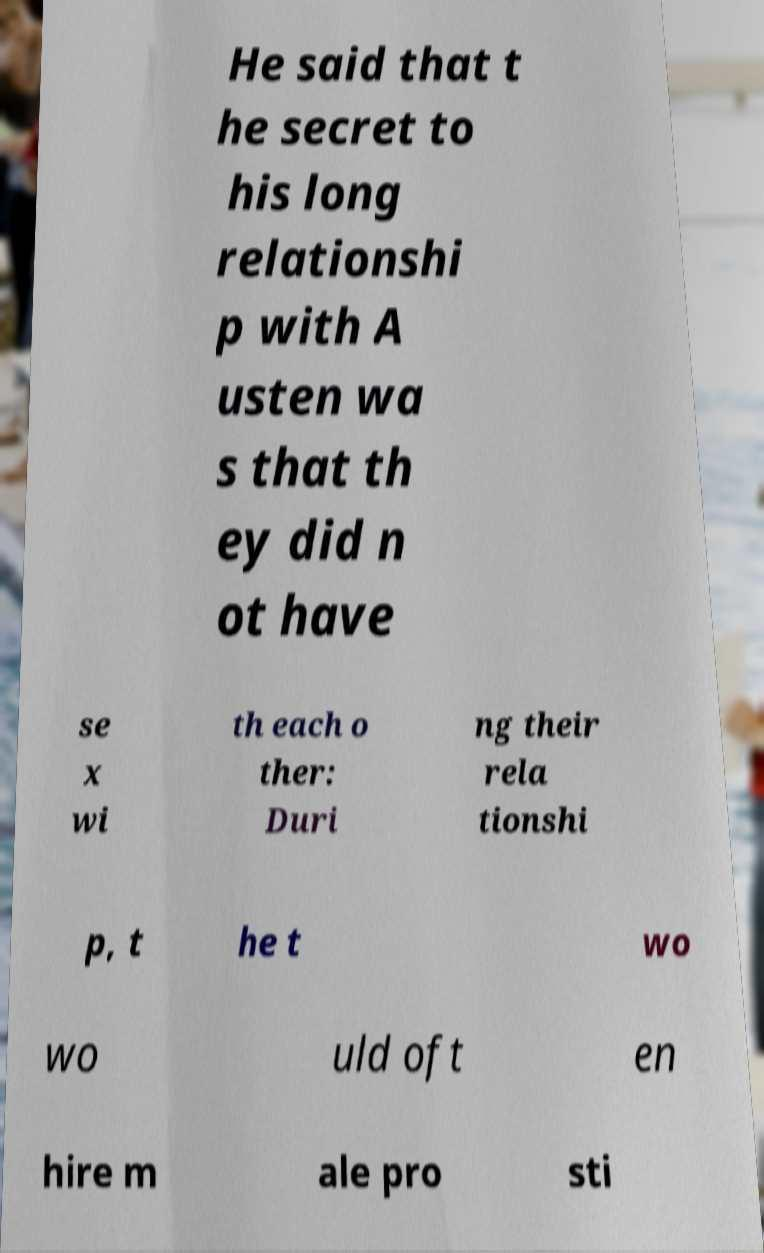For documentation purposes, I need the text within this image transcribed. Could you provide that? He said that t he secret to his long relationshi p with A usten wa s that th ey did n ot have se x wi th each o ther: Duri ng their rela tionshi p, t he t wo wo uld oft en hire m ale pro sti 